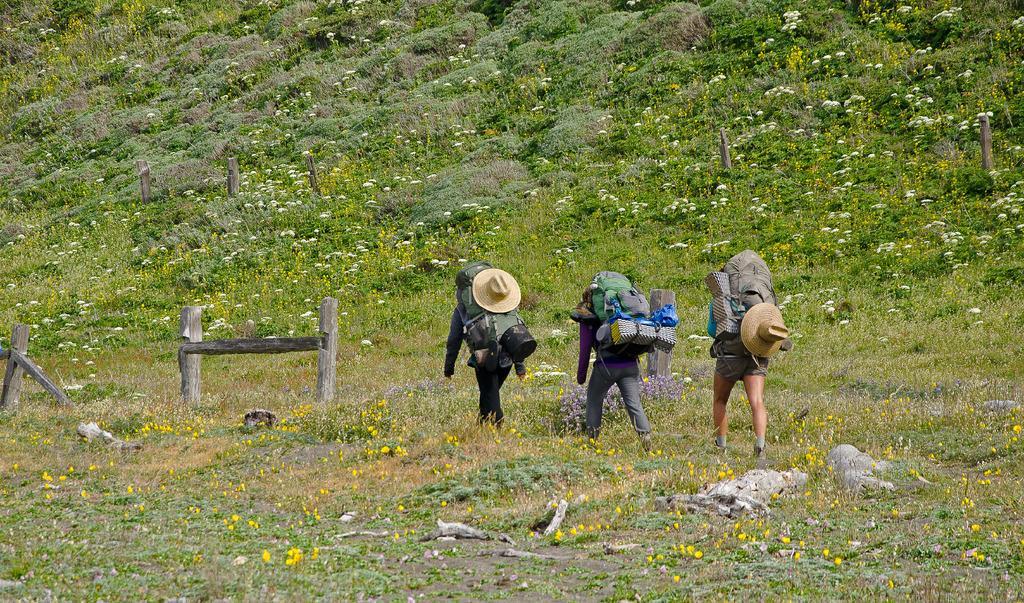Could you give a brief overview of what you see in this image? This is an outside view. Here I can see three persons wearing bags and walking on the ground. Here I can see many flower plants. On the left side there are few wooden sticks. 